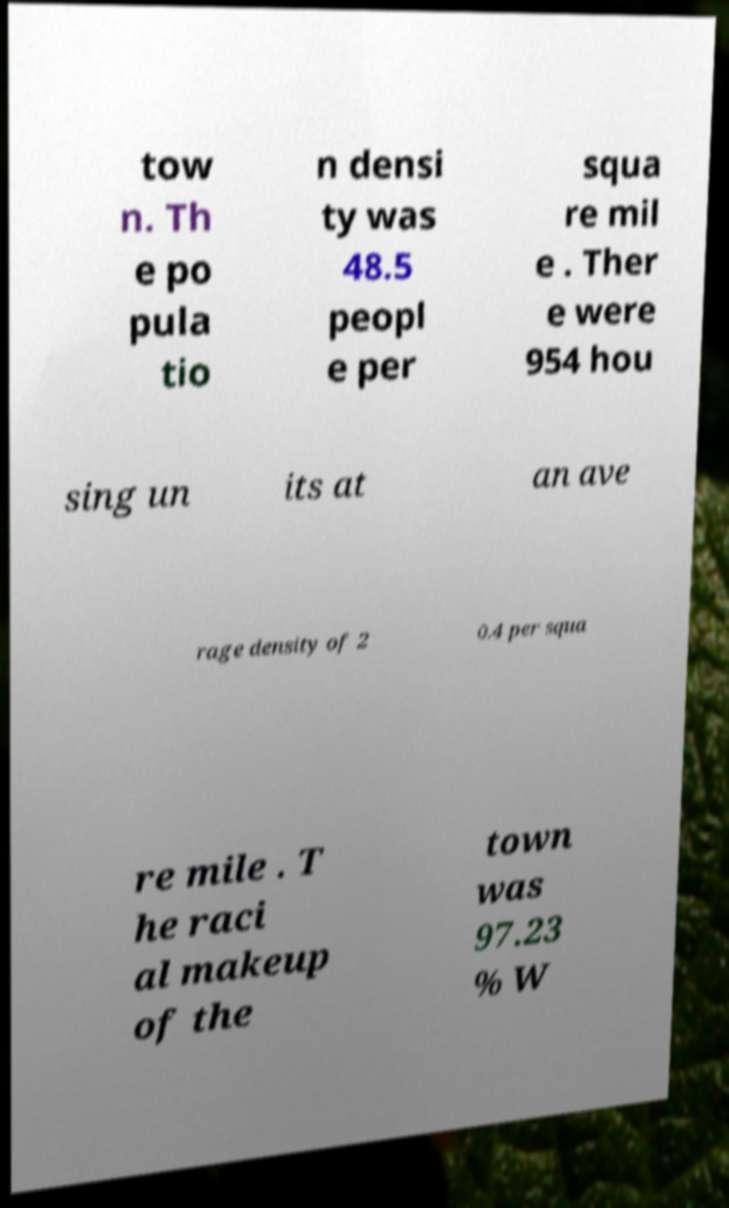Can you read and provide the text displayed in the image?This photo seems to have some interesting text. Can you extract and type it out for me? tow n. Th e po pula tio n densi ty was 48.5 peopl e per squa re mil e . Ther e were 954 hou sing un its at an ave rage density of 2 0.4 per squa re mile . T he raci al makeup of the town was 97.23 % W 